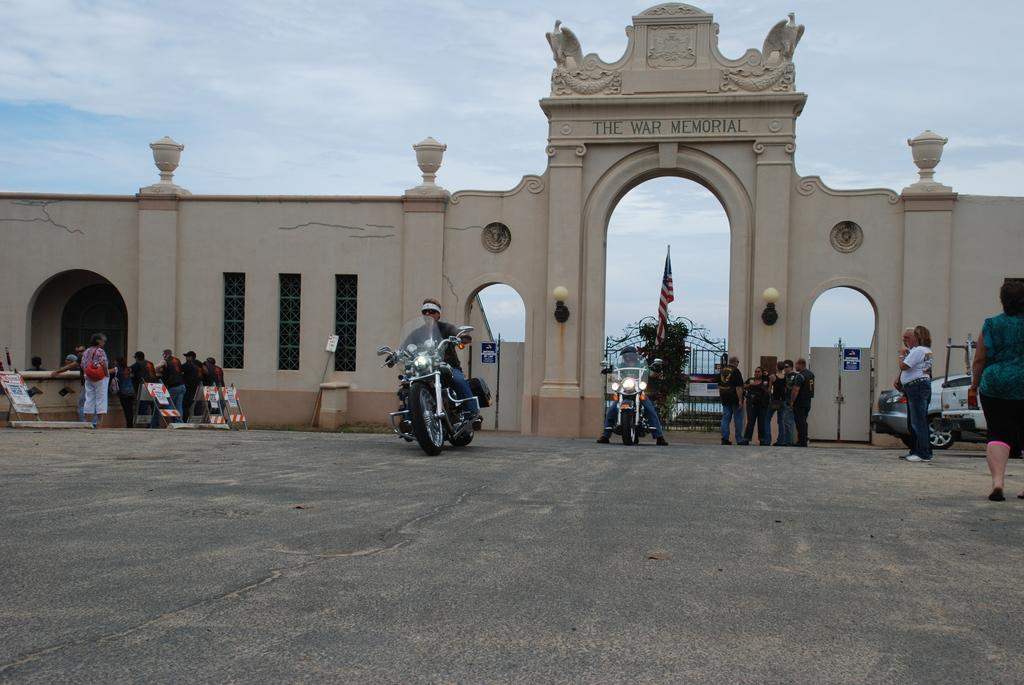What type of structure can be seen in the image? There is a wall in the image. What architectural features are present in the wall? There are windows, doors, and gates in the image. Who or what can be seen in the image? There are people and vehicles in the image. What additional objects are present in the image? There is a poster and a flag in the image. What can be seen in the background of the image? The sky is visible in the background of the image. How many masks are being worn by the people in the image? There are no masks visible in the image; the people are not wearing any. What type of fan is being used by the people in the image? There is no fan present in the image. 